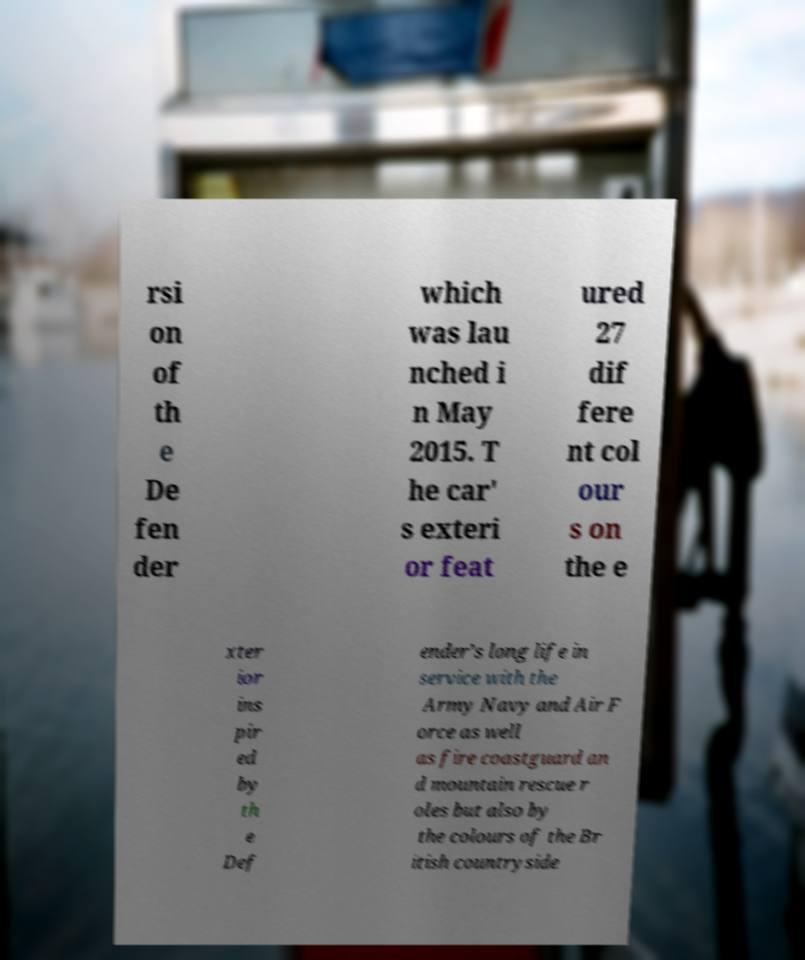For documentation purposes, I need the text within this image transcribed. Could you provide that? rsi on of th e De fen der which was lau nched i n May 2015. T he car' s exteri or feat ured 27 dif fere nt col our s on the e xter ior ins pir ed by th e Def ender’s long life in service with the Army Navy and Air F orce as well as fire coastguard an d mountain rescue r oles but also by the colours of the Br itish countryside 